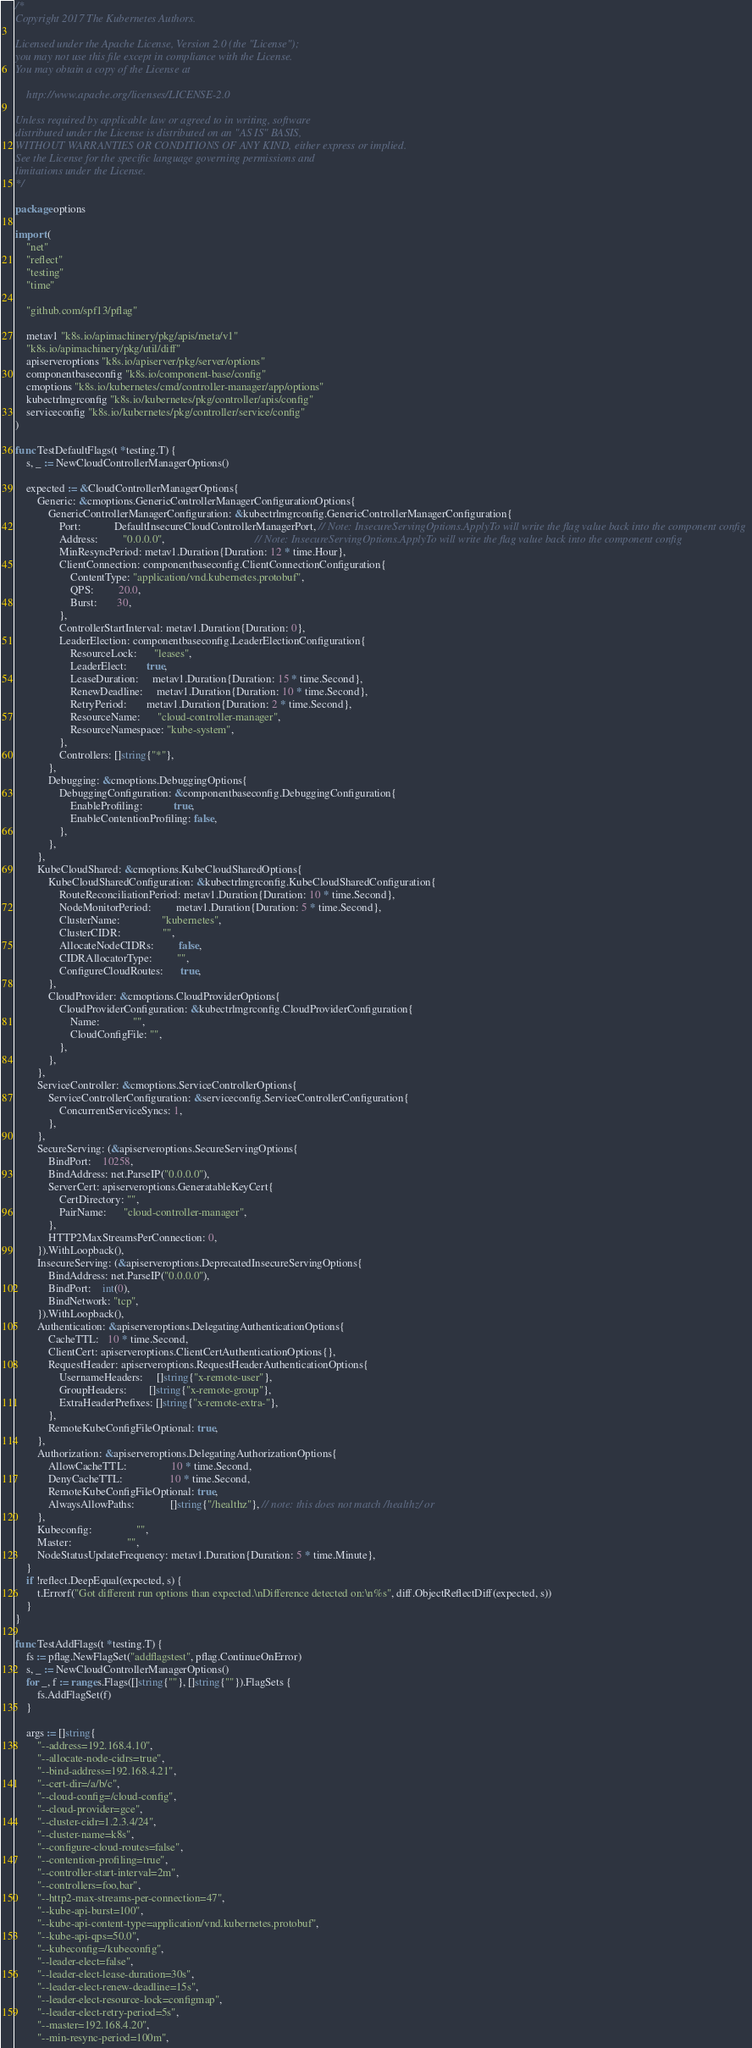<code> <loc_0><loc_0><loc_500><loc_500><_Go_>/*
Copyright 2017 The Kubernetes Authors.

Licensed under the Apache License, Version 2.0 (the "License");
you may not use this file except in compliance with the License.
You may obtain a copy of the License at

    http://www.apache.org/licenses/LICENSE-2.0

Unless required by applicable law or agreed to in writing, software
distributed under the License is distributed on an "AS IS" BASIS,
WITHOUT WARRANTIES OR CONDITIONS OF ANY KIND, either express or implied.
See the License for the specific language governing permissions and
limitations under the License.
*/

package options

import (
	"net"
	"reflect"
	"testing"
	"time"

	"github.com/spf13/pflag"

	metav1 "k8s.io/apimachinery/pkg/apis/meta/v1"
	"k8s.io/apimachinery/pkg/util/diff"
	apiserveroptions "k8s.io/apiserver/pkg/server/options"
	componentbaseconfig "k8s.io/component-base/config"
	cmoptions "k8s.io/kubernetes/cmd/controller-manager/app/options"
	kubectrlmgrconfig "k8s.io/kubernetes/pkg/controller/apis/config"
	serviceconfig "k8s.io/kubernetes/pkg/controller/service/config"
)

func TestDefaultFlags(t *testing.T) {
	s, _ := NewCloudControllerManagerOptions()

	expected := &CloudControllerManagerOptions{
		Generic: &cmoptions.GenericControllerManagerConfigurationOptions{
			GenericControllerManagerConfiguration: &kubectrlmgrconfig.GenericControllerManagerConfiguration{
				Port:            DefaultInsecureCloudControllerManagerPort, // Note: InsecureServingOptions.ApplyTo will write the flag value back into the component config
				Address:         "0.0.0.0",                                 // Note: InsecureServingOptions.ApplyTo will write the flag value back into the component config
				MinResyncPeriod: metav1.Duration{Duration: 12 * time.Hour},
				ClientConnection: componentbaseconfig.ClientConnectionConfiguration{
					ContentType: "application/vnd.kubernetes.protobuf",
					QPS:         20.0,
					Burst:       30,
				},
				ControllerStartInterval: metav1.Duration{Duration: 0},
				LeaderElection: componentbaseconfig.LeaderElectionConfiguration{
					ResourceLock:      "leases",
					LeaderElect:       true,
					LeaseDuration:     metav1.Duration{Duration: 15 * time.Second},
					RenewDeadline:     metav1.Duration{Duration: 10 * time.Second},
					RetryPeriod:       metav1.Duration{Duration: 2 * time.Second},
					ResourceName:      "cloud-controller-manager",
					ResourceNamespace: "kube-system",
				},
				Controllers: []string{"*"},
			},
			Debugging: &cmoptions.DebuggingOptions{
				DebuggingConfiguration: &componentbaseconfig.DebuggingConfiguration{
					EnableProfiling:           true,
					EnableContentionProfiling: false,
				},
			},
		},
		KubeCloudShared: &cmoptions.KubeCloudSharedOptions{
			KubeCloudSharedConfiguration: &kubectrlmgrconfig.KubeCloudSharedConfiguration{
				RouteReconciliationPeriod: metav1.Duration{Duration: 10 * time.Second},
				NodeMonitorPeriod:         metav1.Duration{Duration: 5 * time.Second},
				ClusterName:               "kubernetes",
				ClusterCIDR:               "",
				AllocateNodeCIDRs:         false,
				CIDRAllocatorType:         "",
				ConfigureCloudRoutes:      true,
			},
			CloudProvider: &cmoptions.CloudProviderOptions{
				CloudProviderConfiguration: &kubectrlmgrconfig.CloudProviderConfiguration{
					Name:            "",
					CloudConfigFile: "",
				},
			},
		},
		ServiceController: &cmoptions.ServiceControllerOptions{
			ServiceControllerConfiguration: &serviceconfig.ServiceControllerConfiguration{
				ConcurrentServiceSyncs: 1,
			},
		},
		SecureServing: (&apiserveroptions.SecureServingOptions{
			BindPort:    10258,
			BindAddress: net.ParseIP("0.0.0.0"),
			ServerCert: apiserveroptions.GeneratableKeyCert{
				CertDirectory: "",
				PairName:      "cloud-controller-manager",
			},
			HTTP2MaxStreamsPerConnection: 0,
		}).WithLoopback(),
		InsecureServing: (&apiserveroptions.DeprecatedInsecureServingOptions{
			BindAddress: net.ParseIP("0.0.0.0"),
			BindPort:    int(0),
			BindNetwork: "tcp",
		}).WithLoopback(),
		Authentication: &apiserveroptions.DelegatingAuthenticationOptions{
			CacheTTL:   10 * time.Second,
			ClientCert: apiserveroptions.ClientCertAuthenticationOptions{},
			RequestHeader: apiserveroptions.RequestHeaderAuthenticationOptions{
				UsernameHeaders:     []string{"x-remote-user"},
				GroupHeaders:        []string{"x-remote-group"},
				ExtraHeaderPrefixes: []string{"x-remote-extra-"},
			},
			RemoteKubeConfigFileOptional: true,
		},
		Authorization: &apiserveroptions.DelegatingAuthorizationOptions{
			AllowCacheTTL:                10 * time.Second,
			DenyCacheTTL:                 10 * time.Second,
			RemoteKubeConfigFileOptional: true,
			AlwaysAllowPaths:             []string{"/healthz"}, // note: this does not match /healthz/ or
		},
		Kubeconfig:                "",
		Master:                    "",
		NodeStatusUpdateFrequency: metav1.Duration{Duration: 5 * time.Minute},
	}
	if !reflect.DeepEqual(expected, s) {
		t.Errorf("Got different run options than expected.\nDifference detected on:\n%s", diff.ObjectReflectDiff(expected, s))
	}
}

func TestAddFlags(t *testing.T) {
	fs := pflag.NewFlagSet("addflagstest", pflag.ContinueOnError)
	s, _ := NewCloudControllerManagerOptions()
	for _, f := range s.Flags([]string{""}, []string{""}).FlagSets {
		fs.AddFlagSet(f)
	}

	args := []string{
		"--address=192.168.4.10",
		"--allocate-node-cidrs=true",
		"--bind-address=192.168.4.21",
		"--cert-dir=/a/b/c",
		"--cloud-config=/cloud-config",
		"--cloud-provider=gce",
		"--cluster-cidr=1.2.3.4/24",
		"--cluster-name=k8s",
		"--configure-cloud-routes=false",
		"--contention-profiling=true",
		"--controller-start-interval=2m",
		"--controllers=foo,bar",
		"--http2-max-streams-per-connection=47",
		"--kube-api-burst=100",
		"--kube-api-content-type=application/vnd.kubernetes.protobuf",
		"--kube-api-qps=50.0",
		"--kubeconfig=/kubeconfig",
		"--leader-elect=false",
		"--leader-elect-lease-duration=30s",
		"--leader-elect-renew-deadline=15s",
		"--leader-elect-resource-lock=configmap",
		"--leader-elect-retry-period=5s",
		"--master=192.168.4.20",
		"--min-resync-period=100m",</code> 